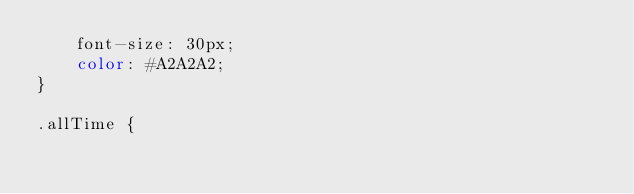<code> <loc_0><loc_0><loc_500><loc_500><_CSS_>    font-size: 30px;
    color: #A2A2A2;
}

.allTime {</code> 